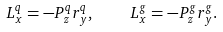<formula> <loc_0><loc_0><loc_500><loc_500>L _ { x } ^ { q } = - P ^ { q } _ { z } r ^ { q } _ { y } , \quad L _ { x } ^ { g } = - P ^ { g } _ { z } r ^ { g } _ { y } .</formula> 